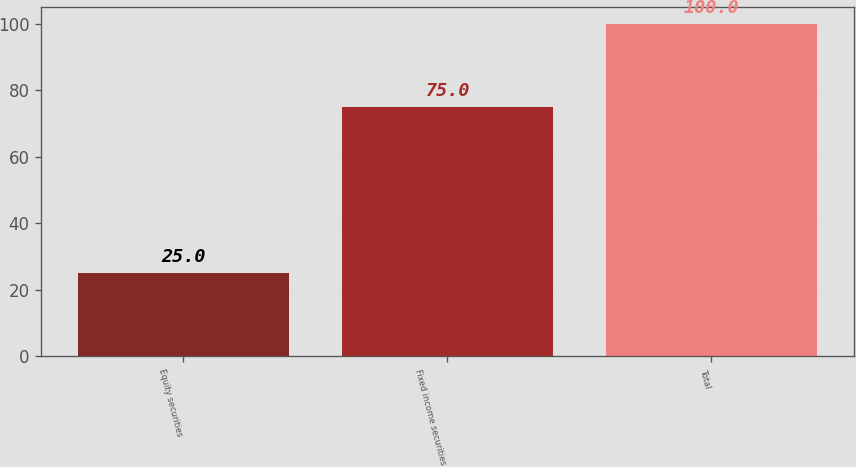Convert chart. <chart><loc_0><loc_0><loc_500><loc_500><bar_chart><fcel>Equity securities<fcel>Fixed income securities<fcel>Total<nl><fcel>25<fcel>75<fcel>100<nl></chart> 